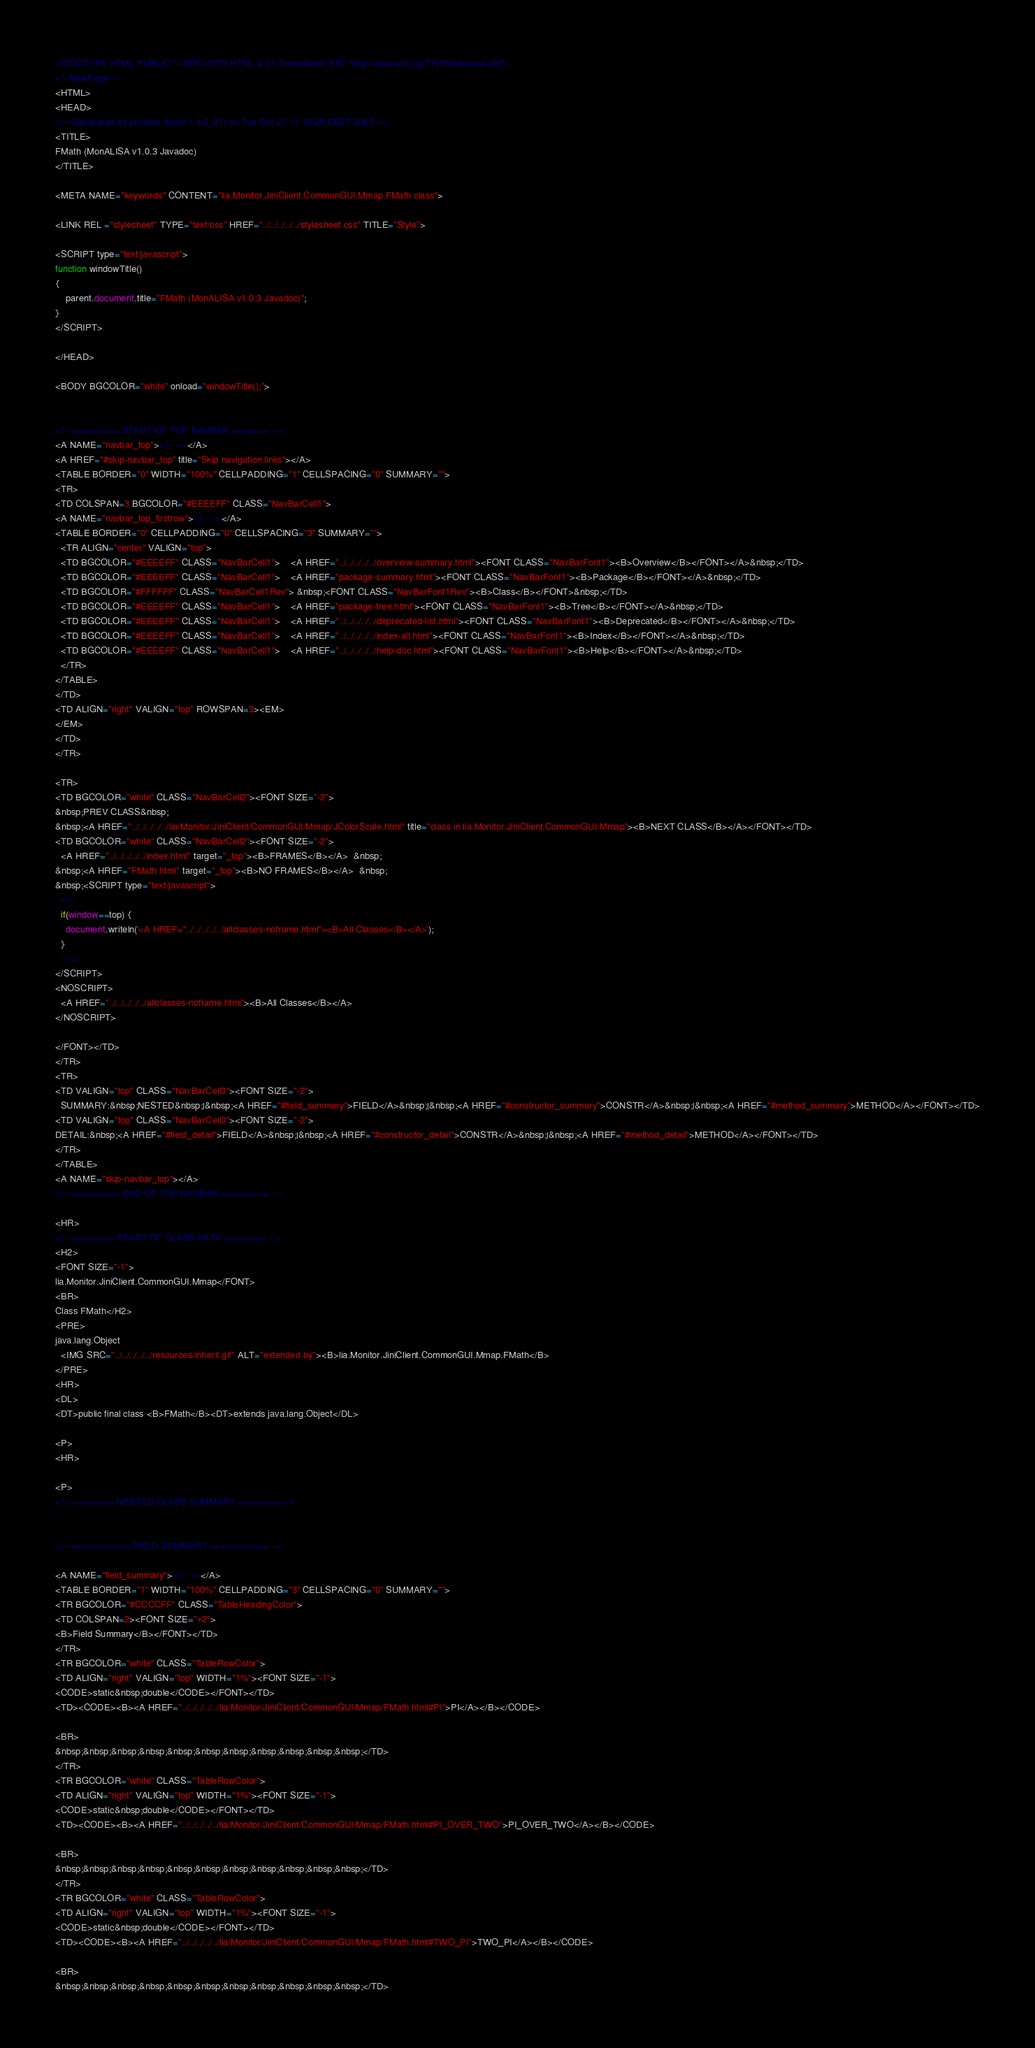Convert code to text. <code><loc_0><loc_0><loc_500><loc_500><_HTML_><!DOCTYPE HTML PUBLIC "-//W3C//DTD HTML 4.01 Transitional//EN" "http://www.w3.org/TR/html4/loose.dtd">
<!--NewPage-->
<HTML>
<HEAD>
<!-- Generated by javadoc (build 1.4.2_01) on Tue Oct 21 11:18:29 EEST 2003 -->
<TITLE>
FMath (MonALISA v1.0.3 Javadoc)
</TITLE>

<META NAME="keywords" CONTENT="lia.Monitor.JiniClient.CommonGUI.Mmap.FMath class">

<LINK REL ="stylesheet" TYPE="text/css" HREF="../../../../../stylesheet.css" TITLE="Style">

<SCRIPT type="text/javascript">
function windowTitle()
{
    parent.document.title="FMath (MonALISA v1.0.3 Javadoc)";
}
</SCRIPT>

</HEAD>

<BODY BGCOLOR="white" onload="windowTitle();">


<!-- ========= START OF TOP NAVBAR ======= -->
<A NAME="navbar_top"><!-- --></A>
<A HREF="#skip-navbar_top" title="Skip navigation links"></A>
<TABLE BORDER="0" WIDTH="100%" CELLPADDING="1" CELLSPACING="0" SUMMARY="">
<TR>
<TD COLSPAN=3 BGCOLOR="#EEEEFF" CLASS="NavBarCell1">
<A NAME="navbar_top_firstrow"><!-- --></A>
<TABLE BORDER="0" CELLPADDING="0" CELLSPACING="3" SUMMARY="">
  <TR ALIGN="center" VALIGN="top">
  <TD BGCOLOR="#EEEEFF" CLASS="NavBarCell1">    <A HREF="../../../../../overview-summary.html"><FONT CLASS="NavBarFont1"><B>Overview</B></FONT></A>&nbsp;</TD>
  <TD BGCOLOR="#EEEEFF" CLASS="NavBarCell1">    <A HREF="package-summary.html"><FONT CLASS="NavBarFont1"><B>Package</B></FONT></A>&nbsp;</TD>
  <TD BGCOLOR="#FFFFFF" CLASS="NavBarCell1Rev"> &nbsp;<FONT CLASS="NavBarFont1Rev"><B>Class</B></FONT>&nbsp;</TD>
  <TD BGCOLOR="#EEEEFF" CLASS="NavBarCell1">    <A HREF="package-tree.html"><FONT CLASS="NavBarFont1"><B>Tree</B></FONT></A>&nbsp;</TD>
  <TD BGCOLOR="#EEEEFF" CLASS="NavBarCell1">    <A HREF="../../../../../deprecated-list.html"><FONT CLASS="NavBarFont1"><B>Deprecated</B></FONT></A>&nbsp;</TD>
  <TD BGCOLOR="#EEEEFF" CLASS="NavBarCell1">    <A HREF="../../../../../index-all.html"><FONT CLASS="NavBarFont1"><B>Index</B></FONT></A>&nbsp;</TD>
  <TD BGCOLOR="#EEEEFF" CLASS="NavBarCell1">    <A HREF="../../../../../help-doc.html"><FONT CLASS="NavBarFont1"><B>Help</B></FONT></A>&nbsp;</TD>
  </TR>
</TABLE>
</TD>
<TD ALIGN="right" VALIGN="top" ROWSPAN=3><EM>
</EM>
</TD>
</TR>

<TR>
<TD BGCOLOR="white" CLASS="NavBarCell2"><FONT SIZE="-2">
&nbsp;PREV CLASS&nbsp;
&nbsp;<A HREF="../../../../../lia/Monitor/JiniClient/CommonGUI/Mmap/JColorScale.html" title="class in lia.Monitor.JiniClient.CommonGUI.Mmap"><B>NEXT CLASS</B></A></FONT></TD>
<TD BGCOLOR="white" CLASS="NavBarCell2"><FONT SIZE="-2">
  <A HREF="../../../../../index.html" target="_top"><B>FRAMES</B></A>  &nbsp;
&nbsp;<A HREF="FMath.html" target="_top"><B>NO FRAMES</B></A>  &nbsp;
&nbsp;<SCRIPT type="text/javascript">
  <!--
  if(window==top) {
    document.writeln('<A HREF="../../../../../allclasses-noframe.html"><B>All Classes</B></A>');
  }
  //-->
</SCRIPT>
<NOSCRIPT>
  <A HREF="../../../../../allclasses-noframe.html"><B>All Classes</B></A>
</NOSCRIPT>

</FONT></TD>
</TR>
<TR>
<TD VALIGN="top" CLASS="NavBarCell3"><FONT SIZE="-2">
  SUMMARY:&nbsp;NESTED&nbsp;|&nbsp;<A HREF="#field_summary">FIELD</A>&nbsp;|&nbsp;<A HREF="#constructor_summary">CONSTR</A>&nbsp;|&nbsp;<A HREF="#method_summary">METHOD</A></FONT></TD>
<TD VALIGN="top" CLASS="NavBarCell3"><FONT SIZE="-2">
DETAIL:&nbsp;<A HREF="#field_detail">FIELD</A>&nbsp;|&nbsp;<A HREF="#constructor_detail">CONSTR</A>&nbsp;|&nbsp;<A HREF="#method_detail">METHOD</A></FONT></TD>
</TR>
</TABLE>
<A NAME="skip-navbar_top"></A>
<!-- ========= END OF TOP NAVBAR ========= -->

<HR>
<!-- ======== START OF CLASS DATA ======== -->
<H2>
<FONT SIZE="-1">
lia.Monitor.JiniClient.CommonGUI.Mmap</FONT>
<BR>
Class FMath</H2>
<PRE>
java.lang.Object
  <IMG SRC="../../../../../resources/inherit.gif" ALT="extended by"><B>lia.Monitor.JiniClient.CommonGUI.Mmap.FMath</B>
</PRE>
<HR>
<DL>
<DT>public final class <B>FMath</B><DT>extends java.lang.Object</DL>

<P>
<HR>

<P>
<!-- ======== NESTED CLASS SUMMARY ======== -->


<!-- =========== FIELD SUMMARY =========== -->

<A NAME="field_summary"><!-- --></A>
<TABLE BORDER="1" WIDTH="100%" CELLPADDING="3" CELLSPACING="0" SUMMARY="">
<TR BGCOLOR="#CCCCFF" CLASS="TableHeadingColor">
<TD COLSPAN=2><FONT SIZE="+2">
<B>Field Summary</B></FONT></TD>
</TR>
<TR BGCOLOR="white" CLASS="TableRowColor">
<TD ALIGN="right" VALIGN="top" WIDTH="1%"><FONT SIZE="-1">
<CODE>static&nbsp;double</CODE></FONT></TD>
<TD><CODE><B><A HREF="../../../../../lia/Monitor/JiniClient/CommonGUI/Mmap/FMath.html#PI">PI</A></B></CODE>

<BR>
&nbsp;&nbsp;&nbsp;&nbsp;&nbsp;&nbsp;&nbsp;&nbsp;&nbsp;&nbsp;&nbsp;</TD>
</TR>
<TR BGCOLOR="white" CLASS="TableRowColor">
<TD ALIGN="right" VALIGN="top" WIDTH="1%"><FONT SIZE="-1">
<CODE>static&nbsp;double</CODE></FONT></TD>
<TD><CODE><B><A HREF="../../../../../lia/Monitor/JiniClient/CommonGUI/Mmap/FMath.html#PI_OVER_TWO">PI_OVER_TWO</A></B></CODE>

<BR>
&nbsp;&nbsp;&nbsp;&nbsp;&nbsp;&nbsp;&nbsp;&nbsp;&nbsp;&nbsp;&nbsp;</TD>
</TR>
<TR BGCOLOR="white" CLASS="TableRowColor">
<TD ALIGN="right" VALIGN="top" WIDTH="1%"><FONT SIZE="-1">
<CODE>static&nbsp;double</CODE></FONT></TD>
<TD><CODE><B><A HREF="../../../../../lia/Monitor/JiniClient/CommonGUI/Mmap/FMath.html#TWO_PI">TWO_PI</A></B></CODE>

<BR>
&nbsp;&nbsp;&nbsp;&nbsp;&nbsp;&nbsp;&nbsp;&nbsp;&nbsp;&nbsp;&nbsp;</TD></code> 